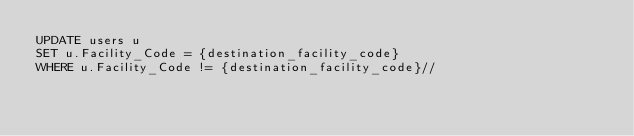Convert code to text. <code><loc_0><loc_0><loc_500><loc_500><_SQL_>UPDATE users u 
SET u.Facility_Code = {destination_facility_code}
WHERE u.Facility_Code != {destination_facility_code}//</code> 